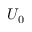<formula> <loc_0><loc_0><loc_500><loc_500>U _ { 0 }</formula> 